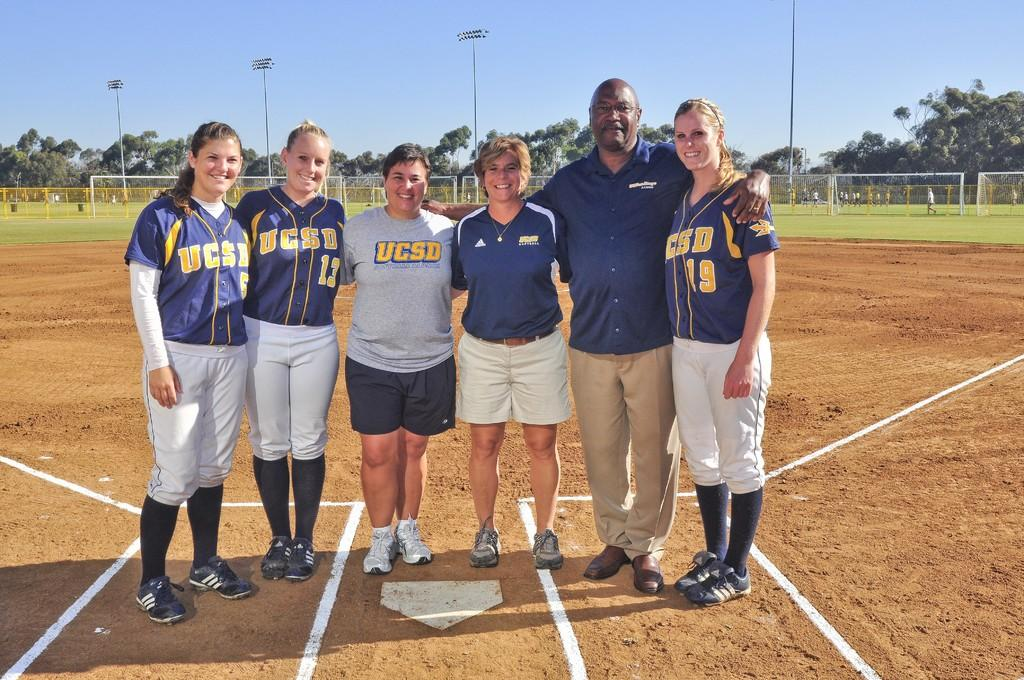<image>
Summarize the visual content of the image. A picture of baseball player with the coach and one of them have the number 19 on her Jersey. 